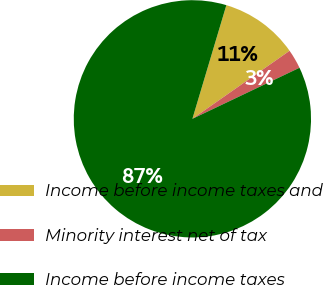Convert chart. <chart><loc_0><loc_0><loc_500><loc_500><pie_chart><fcel>Income before income taxes and<fcel>Minority interest net of tax<fcel>Income before income taxes<nl><fcel>10.66%<fcel>2.64%<fcel>86.7%<nl></chart> 